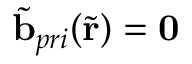Convert formula to latex. <formula><loc_0><loc_0><loc_500><loc_500>\tilde { b } _ { p r i } ( \tilde { r } ) = 0</formula> 